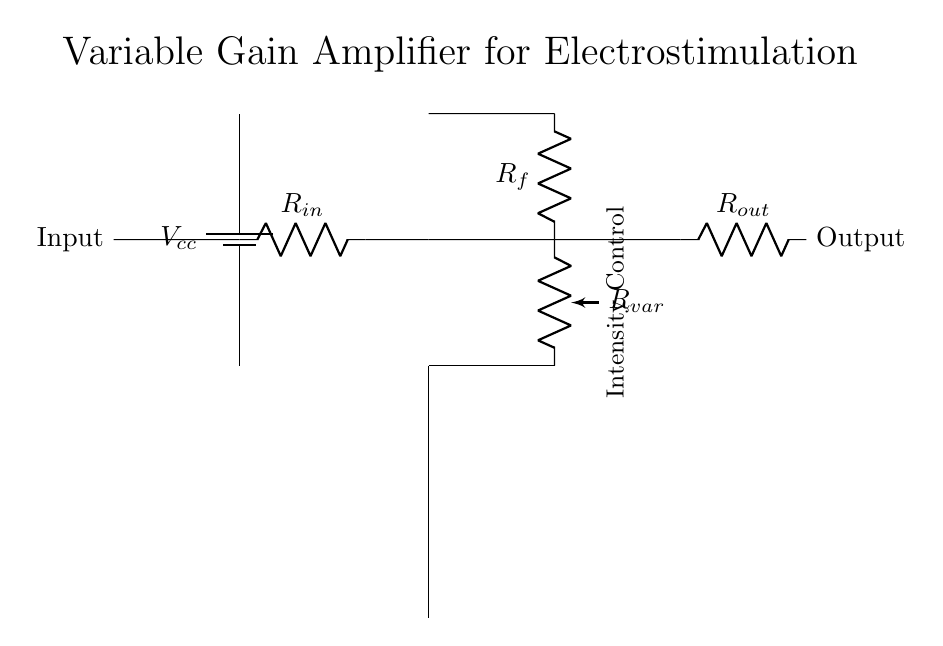What is the input component of this circuit? The input component is a resistor labeled R_in, which connects the input signal to the operational amplifier.
Answer: R_in What does R_var control in this circuit? R_var is a variable resistor that adjusts the feedback to the operational amplifier, thereby controlling the gain and output intensity of the circuit.
Answer: Intensity What type of amplifier is this circuit designed to be? The circuit is a variable gain amplifier, which allows adjustment of the output signal based on the input signal and feedback configuration.
Answer: Variable gain amplifier How many resistors are present in this circuit? There are three resistors in the circuit: R_in, R_f, and R_var.
Answer: Three What is the role of the operational amplifier in this circuit? The operational amplifier serves as the core component that amplifies the input signal based on the feedback it receives from the resistors, determining the overall gain of the circuit.
Answer: Amplifies What happens if R_var is increased? Increasing R_var increases resistance in the feedback loop, which reduces the gain of the amplifier, resulting in a lower output intensity.
Answer: Reduces gain 